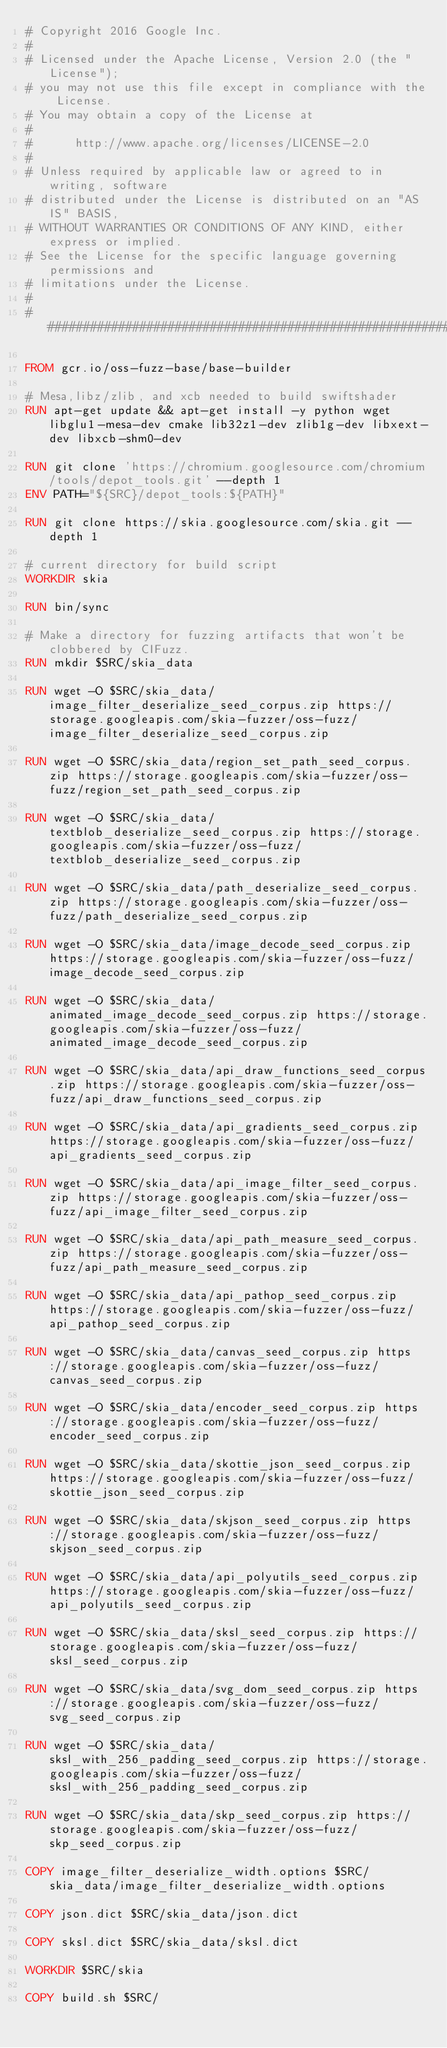<code> <loc_0><loc_0><loc_500><loc_500><_Dockerfile_># Copyright 2016 Google Inc.
#
# Licensed under the Apache License, Version 2.0 (the "License");
# you may not use this file except in compliance with the License.
# You may obtain a copy of the License at
#
#      http://www.apache.org/licenses/LICENSE-2.0
#
# Unless required by applicable law or agreed to in writing, software
# distributed under the License is distributed on an "AS IS" BASIS,
# WITHOUT WARRANTIES OR CONDITIONS OF ANY KIND, either express or implied.
# See the License for the specific language governing permissions and
# limitations under the License.
#
################################################################################

FROM gcr.io/oss-fuzz-base/base-builder

# Mesa,libz/zlib, and xcb needed to build swiftshader
RUN apt-get update && apt-get install -y python wget libglu1-mesa-dev cmake lib32z1-dev zlib1g-dev libxext-dev libxcb-shm0-dev

RUN git clone 'https://chromium.googlesource.com/chromium/tools/depot_tools.git' --depth 1
ENV PATH="${SRC}/depot_tools:${PATH}"

RUN git clone https://skia.googlesource.com/skia.git --depth 1

# current directory for build script
WORKDIR skia

RUN bin/sync

# Make a directory for fuzzing artifacts that won't be clobbered by CIFuzz.
RUN mkdir $SRC/skia_data

RUN wget -O $SRC/skia_data/image_filter_deserialize_seed_corpus.zip https://storage.googleapis.com/skia-fuzzer/oss-fuzz/image_filter_deserialize_seed_corpus.zip

RUN wget -O $SRC/skia_data/region_set_path_seed_corpus.zip https://storage.googleapis.com/skia-fuzzer/oss-fuzz/region_set_path_seed_corpus.zip

RUN wget -O $SRC/skia_data/textblob_deserialize_seed_corpus.zip https://storage.googleapis.com/skia-fuzzer/oss-fuzz/textblob_deserialize_seed_corpus.zip

RUN wget -O $SRC/skia_data/path_deserialize_seed_corpus.zip https://storage.googleapis.com/skia-fuzzer/oss-fuzz/path_deserialize_seed_corpus.zip

RUN wget -O $SRC/skia_data/image_decode_seed_corpus.zip https://storage.googleapis.com/skia-fuzzer/oss-fuzz/image_decode_seed_corpus.zip

RUN wget -O $SRC/skia_data/animated_image_decode_seed_corpus.zip https://storage.googleapis.com/skia-fuzzer/oss-fuzz/animated_image_decode_seed_corpus.zip

RUN wget -O $SRC/skia_data/api_draw_functions_seed_corpus.zip https://storage.googleapis.com/skia-fuzzer/oss-fuzz/api_draw_functions_seed_corpus.zip

RUN wget -O $SRC/skia_data/api_gradients_seed_corpus.zip https://storage.googleapis.com/skia-fuzzer/oss-fuzz/api_gradients_seed_corpus.zip

RUN wget -O $SRC/skia_data/api_image_filter_seed_corpus.zip https://storage.googleapis.com/skia-fuzzer/oss-fuzz/api_image_filter_seed_corpus.zip

RUN wget -O $SRC/skia_data/api_path_measure_seed_corpus.zip https://storage.googleapis.com/skia-fuzzer/oss-fuzz/api_path_measure_seed_corpus.zip

RUN wget -O $SRC/skia_data/api_pathop_seed_corpus.zip https://storage.googleapis.com/skia-fuzzer/oss-fuzz/api_pathop_seed_corpus.zip

RUN wget -O $SRC/skia_data/canvas_seed_corpus.zip https://storage.googleapis.com/skia-fuzzer/oss-fuzz/canvas_seed_corpus.zip

RUN wget -O $SRC/skia_data/encoder_seed_corpus.zip https://storage.googleapis.com/skia-fuzzer/oss-fuzz/encoder_seed_corpus.zip

RUN wget -O $SRC/skia_data/skottie_json_seed_corpus.zip https://storage.googleapis.com/skia-fuzzer/oss-fuzz/skottie_json_seed_corpus.zip

RUN wget -O $SRC/skia_data/skjson_seed_corpus.zip https://storage.googleapis.com/skia-fuzzer/oss-fuzz/skjson_seed_corpus.zip

RUN wget -O $SRC/skia_data/api_polyutils_seed_corpus.zip https://storage.googleapis.com/skia-fuzzer/oss-fuzz/api_polyutils_seed_corpus.zip

RUN wget -O $SRC/skia_data/sksl_seed_corpus.zip https://storage.googleapis.com/skia-fuzzer/oss-fuzz/sksl_seed_corpus.zip

RUN wget -O $SRC/skia_data/svg_dom_seed_corpus.zip https://storage.googleapis.com/skia-fuzzer/oss-fuzz/svg_seed_corpus.zip

RUN wget -O $SRC/skia_data/sksl_with_256_padding_seed_corpus.zip https://storage.googleapis.com/skia-fuzzer/oss-fuzz/sksl_with_256_padding_seed_corpus.zip

RUN wget -O $SRC/skia_data/skp_seed_corpus.zip https://storage.googleapis.com/skia-fuzzer/oss-fuzz/skp_seed_corpus.zip

COPY image_filter_deserialize_width.options $SRC/skia_data/image_filter_deserialize_width.options

COPY json.dict $SRC/skia_data/json.dict

COPY sksl.dict $SRC/skia_data/sksl.dict

WORKDIR $SRC/skia

COPY build.sh $SRC/
</code> 